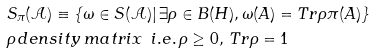Convert formula to latex. <formula><loc_0><loc_0><loc_500><loc_500>& S _ { \pi } ( \mathcal { A } ) \equiv \left \{ \omega \in S ( \mathcal { A } ) | \, \exists \rho \in B ( H ) , \omega ( A ) = T r \rho \pi ( A ) \right \} \\ & \rho \, d e n s i t y \, m a t r i x \, \ i . e . \, \rho \geq 0 , \, T r \rho = 1</formula> 